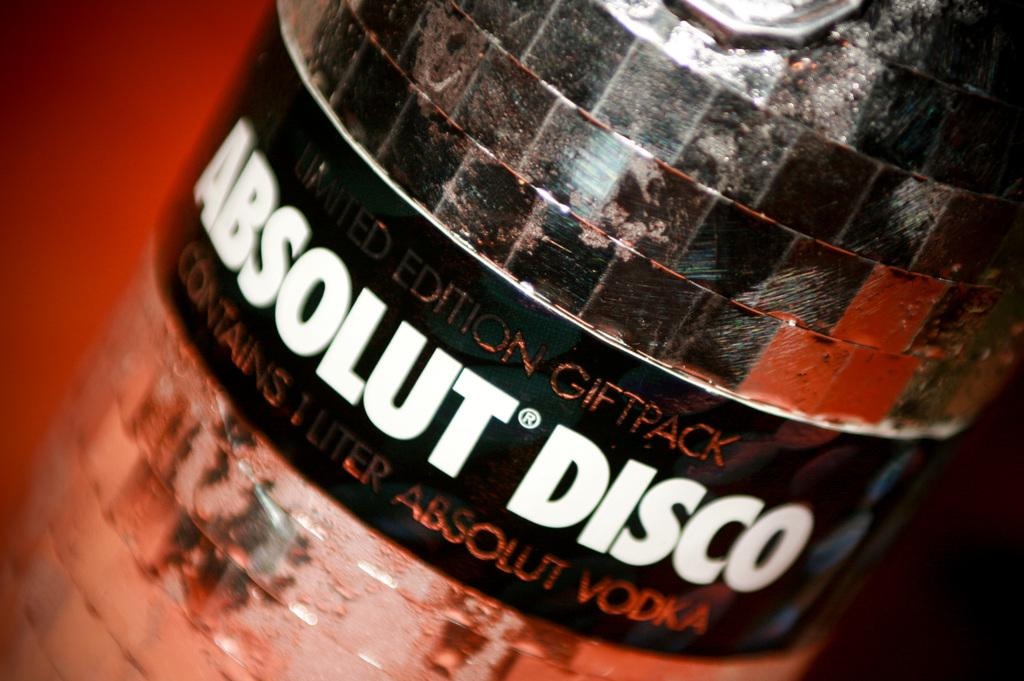What object can be seen in the image? There is a bottle in the image. How many mice are playing in the cemetery near the harbor in the image? There are no mice, cemetery, or harbor present in the image; it only features a bottle. 